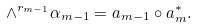<formula> <loc_0><loc_0><loc_500><loc_500>\wedge ^ { r _ { m - 1 } } \alpha _ { m - 1 } = a _ { m - 1 } \circ a _ { m } ^ { * } .</formula> 